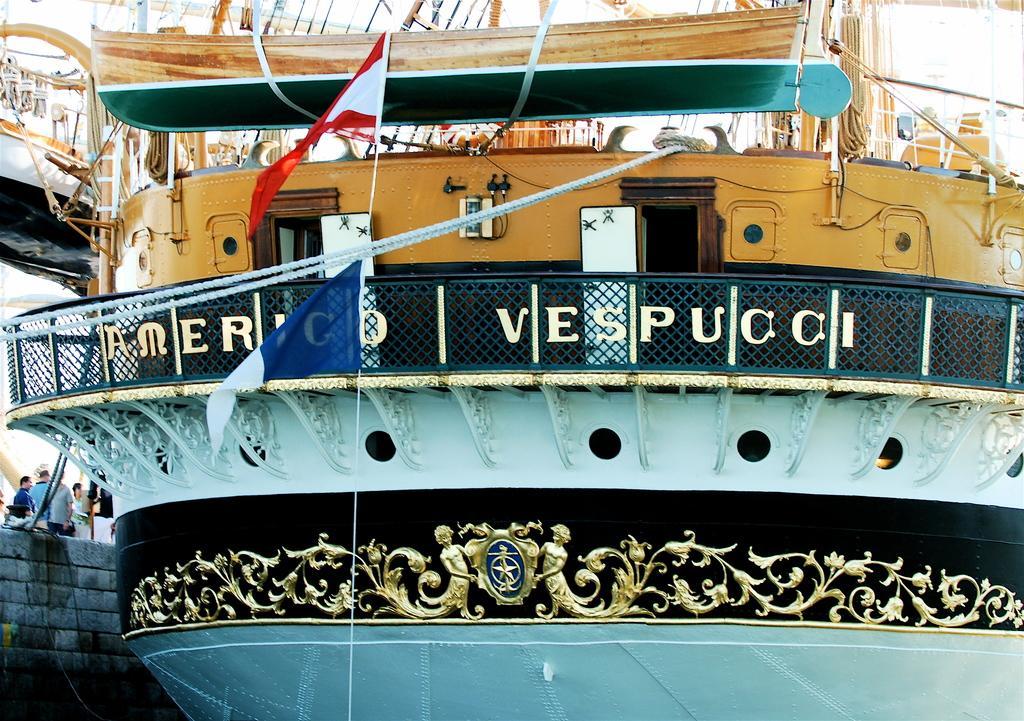Could you give a brief overview of what you see in this image? In this picture we can see a ship, beside to the ship we can find few people, and also we can see flags. 